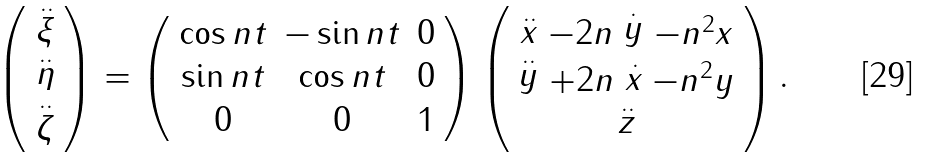<formula> <loc_0><loc_0><loc_500><loc_500>\left ( \begin{array} { c } \stackrel { . . } { \xi } \\ \stackrel { . . } { \eta } \\ \stackrel { . . } { \zeta } \end{array} \right ) = \left ( \begin{array} { c c c } \cos n t & - \sin n t & 0 \\ \sin n t & \cos n t & 0 \\ 0 & 0 & 1 \end{array} \right ) \left ( \begin{array} { c } \stackrel { . . } { x } - 2 n \stackrel { . } { y } - n ^ { 2 } x \\ \stackrel { . . } { y } + 2 n \stackrel { . } { x } - n ^ { 2 } y \\ \stackrel { . . } { z } \end{array} \right ) .</formula> 